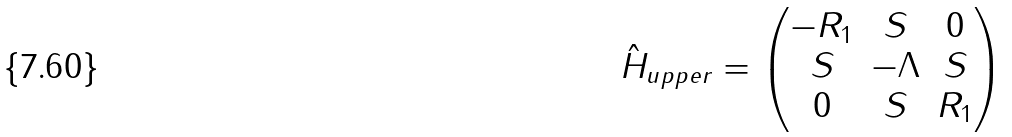Convert formula to latex. <formula><loc_0><loc_0><loc_500><loc_500>\hat { H } _ { u p p e r } = \begin{pmatrix} - R _ { 1 } & S & 0 \\ S & - \Lambda & S \\ 0 & S & R _ { 1 } \\ \end{pmatrix}</formula> 